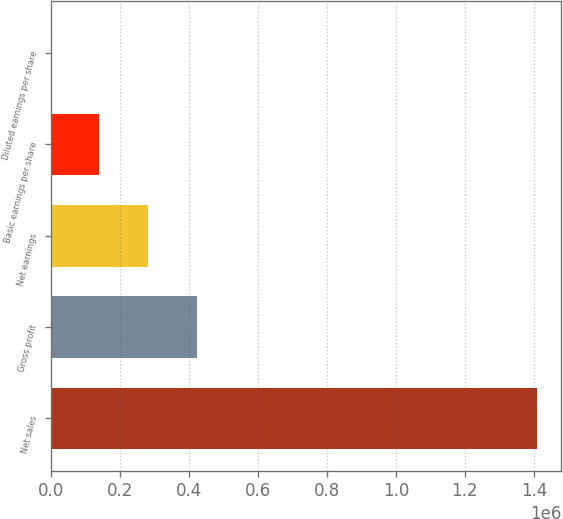<chart> <loc_0><loc_0><loc_500><loc_500><bar_chart><fcel>Net sales<fcel>Gross profit<fcel>Net earnings<fcel>Basic earnings per share<fcel>Diluted earnings per share<nl><fcel>1.40904e+06<fcel>422711<fcel>281807<fcel>140904<fcel>0.58<nl></chart> 